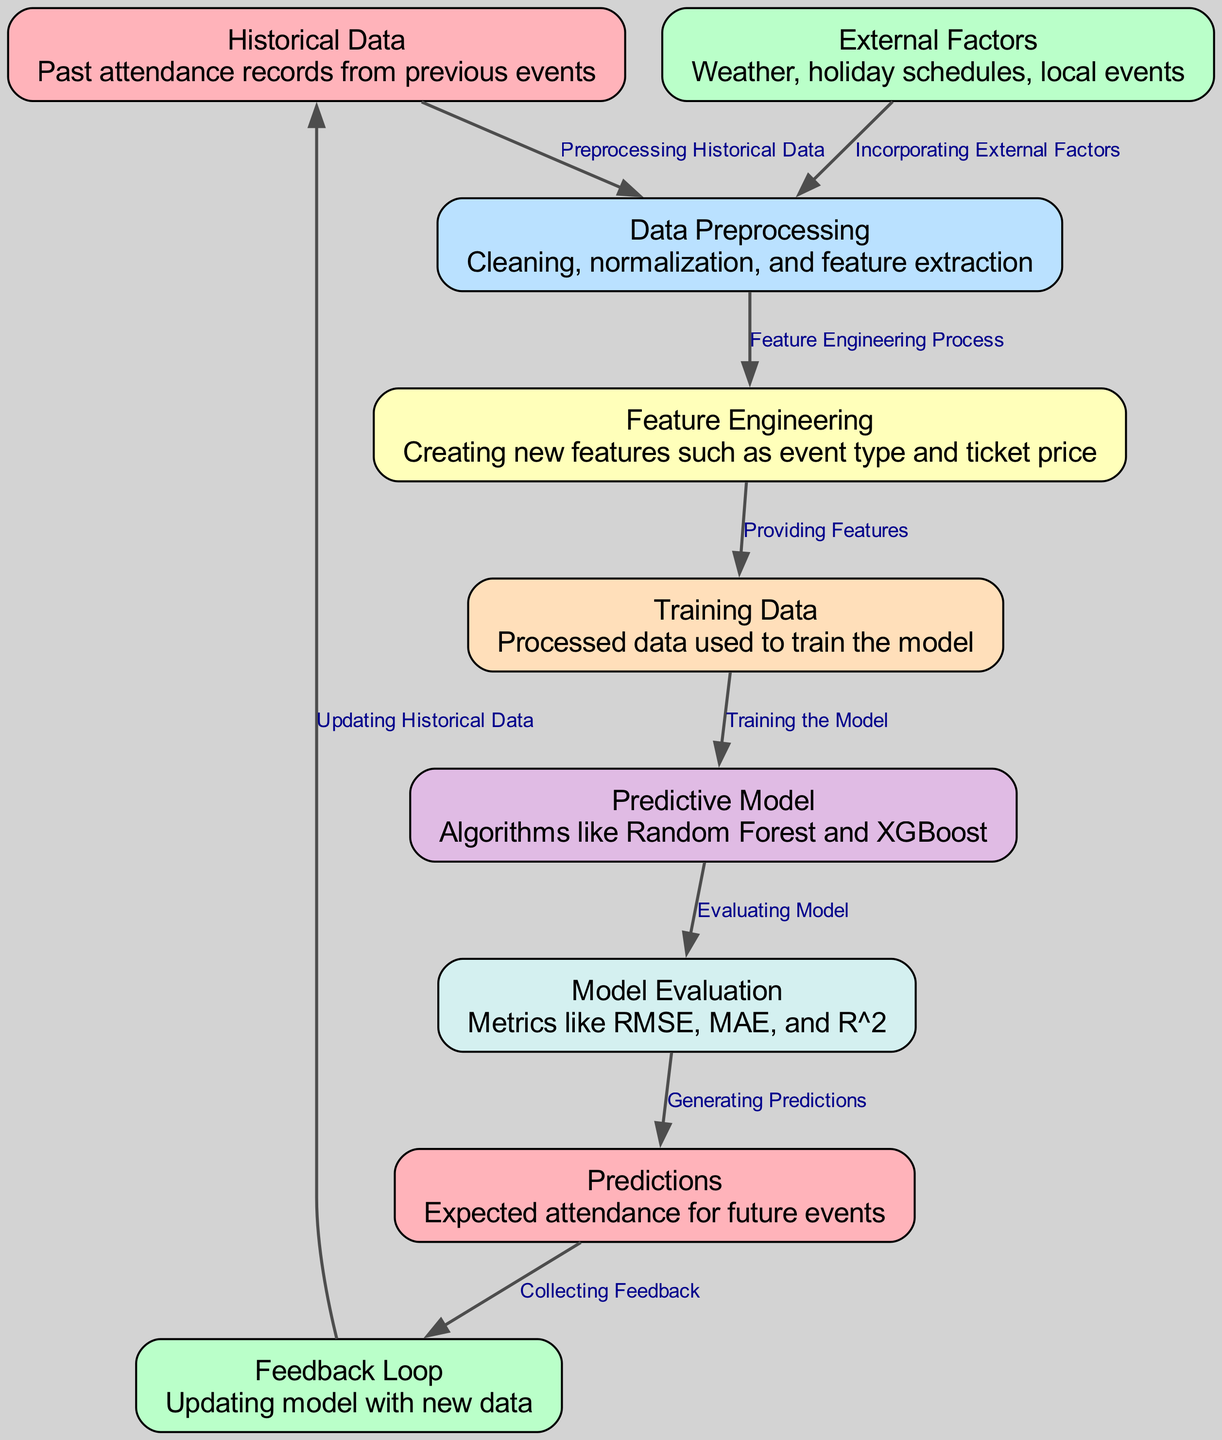What are the two main types of data inputs into this model? The diagram shows two main data inputs: "Historical Data" and "External Factors." These inputs are processed through the model to derive predictions.
Answer: Historical Data and External Factors How many nodes are there in total? By counting the distinct nodes in the diagram representation, we find there are ten nodes representing various stages of the predictive modeling process.
Answer: Ten What is used to train the Predictive Model? The "Training Data" node directly feeds into the "Predictive Model," indicating that the processed data serves this purpose in training the model.
Answer: Training Data Which algorithms are mentioned in the Predictive Model? The diagram describes the algorithms as "Random Forest and XGBoost," highlighting the techniques utilized for making predictions based on input data.
Answer: Random Forest and XGBoost What is the output of the Model Evaluation stage? The edge from "Model Evaluation" to "Predictions" signifies that the outcome of the evaluation process produces expected attendance figures for upcoming events.
Answer: Predictions Which node indicates the process of cleaning the data? The "Data Preprocessing" node specifies that it involves actions like cleaning, normalization, and feature extraction, representing the initial step to prepare the data.
Answer: Data Preprocessing How does the Feedback Loop impact the model? The "Feedback Loop" updates the initial "Historical Data" based on the collected predictions and feedback, thus continually improving the model over time.
Answer: Updating Historical Data What role does Feature Engineering play in this process? The "Feature Engineering" node illustrates that it creates new features, such as event type and ticket price, which are crucial for enhancing model accuracy by providing more informative inputs.
Answer: Providing Features What metrics are used for Model Evaluation? The "Model Evaluation" node mentions metrics like RMSE, MAE, and R^2, which are essential to assess how well the model performs regarding its predictions against actual data.
Answer: RMSE, MAE, and R^2 